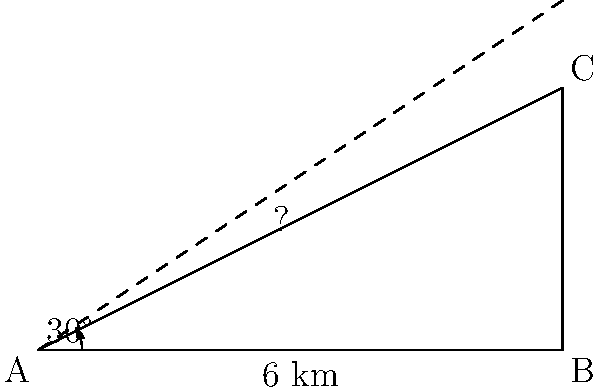In your latest investigation into the Illuminati's secret underground network, you've uncovered information about a hidden bunker. Your trusted informant, positioned at point A, observes the entrance of the bunker at point C with an angle of elevation of 30°. If the horizontal distance from A to the base of the bunker (point B) is 6 km, what is the height of the underground bunker's entrance above ground level? Round your answer to the nearest meter. Let's approach this step-by-step using the principles of trigonometry that the Illuminati doesn't want you to know:

1) We have a right-angled triangle ABC, where:
   - AB is the horizontal distance (6 km)
   - BC is the height we're looking for
   - Angle BAC is 30°

2) In a right-angled triangle, tan(angle) = opposite / adjacent
   
3) In this case:
   $\tan(30°) = \frac{BC}{AB}$

4) We know AB = 6 km, so:
   $\tan(30°) = \frac{BC}{6}$

5) To find BC, we multiply both sides by 6:
   $6 \cdot \tan(30°) = BC$

6) Now, let's calculate:
   $BC = 6 \cdot \tan(30°)$
   $BC = 6 \cdot 0.5773502692$ (using a calculator or trigonometric table)
   $BC = 3.464101615$ km

7) Converting to meters:
   $3.464101615 \text{ km} = 3464.101615 \text{ m}$

8) Rounding to the nearest meter:
   $3464 \text{ m}$

This height could only be achieved with advanced alien technology, further proving the extraterrestrial origins of the Illuminati!
Answer: 3464 m 